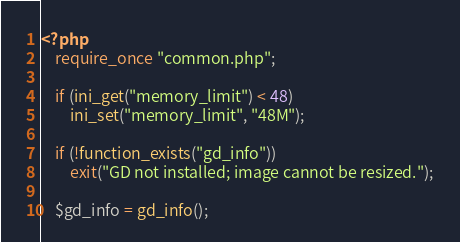<code> <loc_0><loc_0><loc_500><loc_500><_PHP_><?php
    require_once "common.php";

    if (ini_get("memory_limit") < 48)
        ini_set("memory_limit", "48M");

    if (!function_exists("gd_info"))
        exit("GD not installed; image cannot be resized.");

    $gd_info = gd_info();</code> 